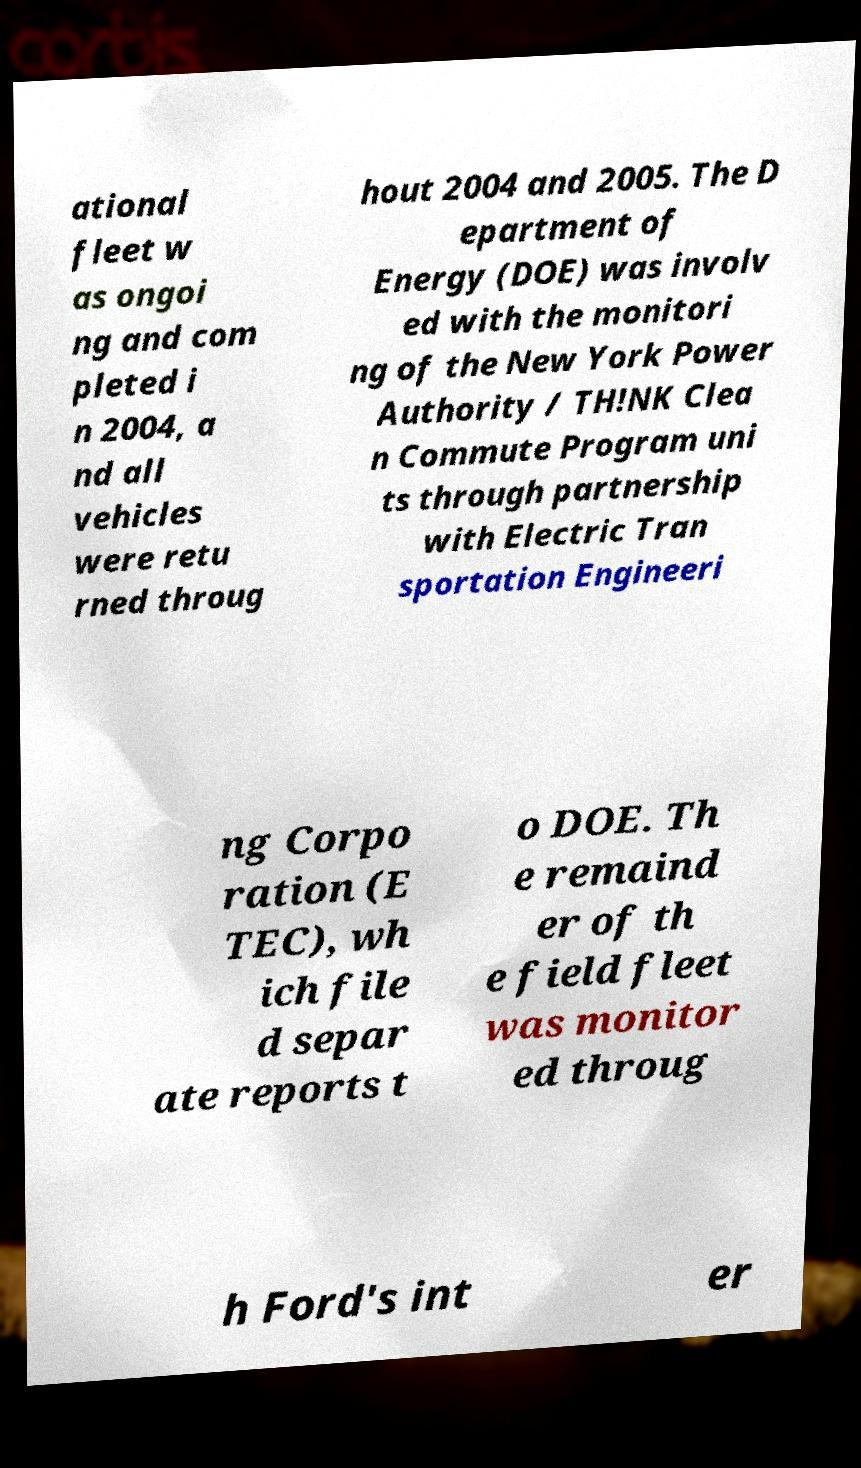What messages or text are displayed in this image? I need them in a readable, typed format. ational fleet w as ongoi ng and com pleted i n 2004, a nd all vehicles were retu rned throug hout 2004 and 2005. The D epartment of Energy (DOE) was involv ed with the monitori ng of the New York Power Authority / TH!NK Clea n Commute Program uni ts through partnership with Electric Tran sportation Engineeri ng Corpo ration (E TEC), wh ich file d separ ate reports t o DOE. Th e remaind er of th e field fleet was monitor ed throug h Ford's int er 